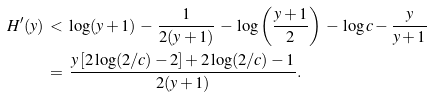Convert formula to latex. <formula><loc_0><loc_0><loc_500><loc_500>H ^ { \prime } ( y ) \, & < \, \log ( y + 1 ) \, - \, \frac { 1 } { 2 ( y + 1 ) } \, - \, \log \left ( \frac { y + 1 } { 2 } \right ) \, - \, \log c - \frac { y } { y + 1 } \\ \, & = \, \frac { y \left [ 2 \log ( 2 / c ) - 2 \right ] + 2 \log ( 2 / c ) - 1 } { 2 ( y + 1 ) } .</formula> 